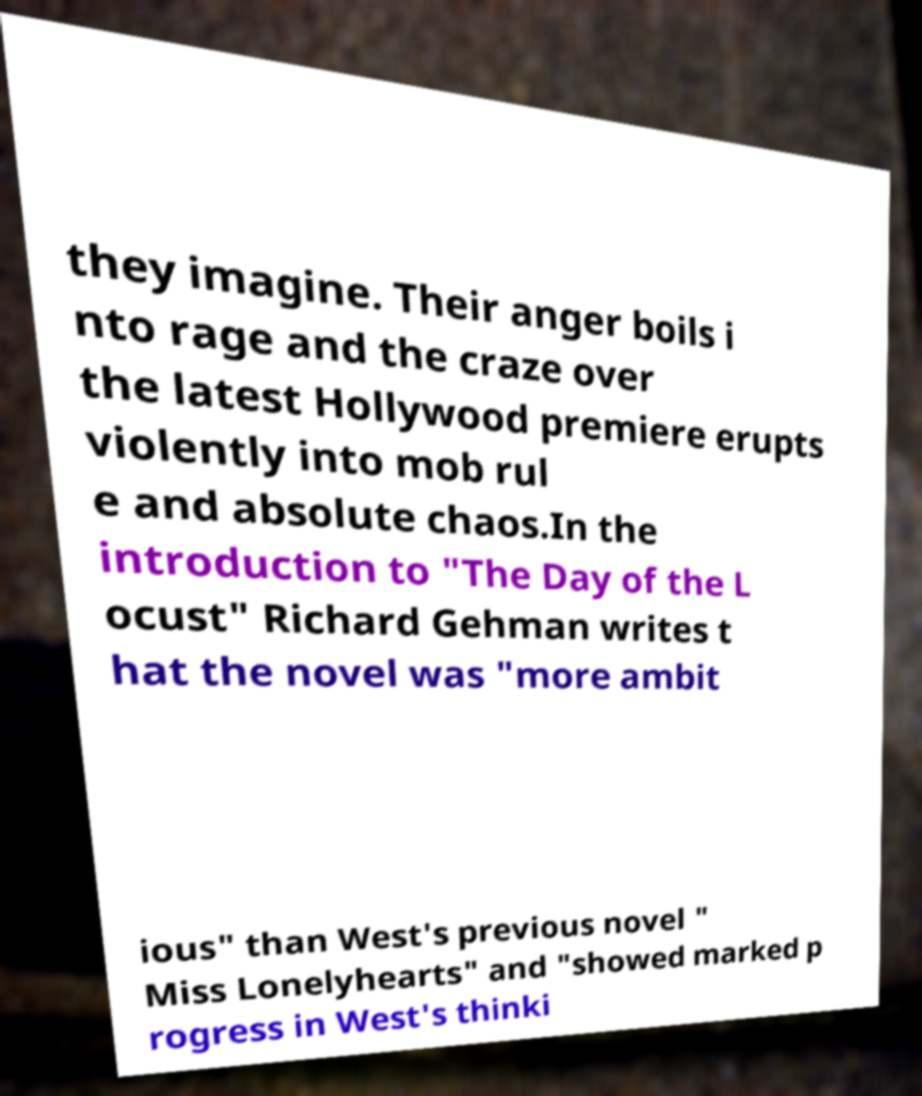Can you read and provide the text displayed in the image?This photo seems to have some interesting text. Can you extract and type it out for me? they imagine. Their anger boils i nto rage and the craze over the latest Hollywood premiere erupts violently into mob rul e and absolute chaos.In the introduction to "The Day of the L ocust" Richard Gehman writes t hat the novel was "more ambit ious" than West's previous novel " Miss Lonelyhearts" and "showed marked p rogress in West's thinki 